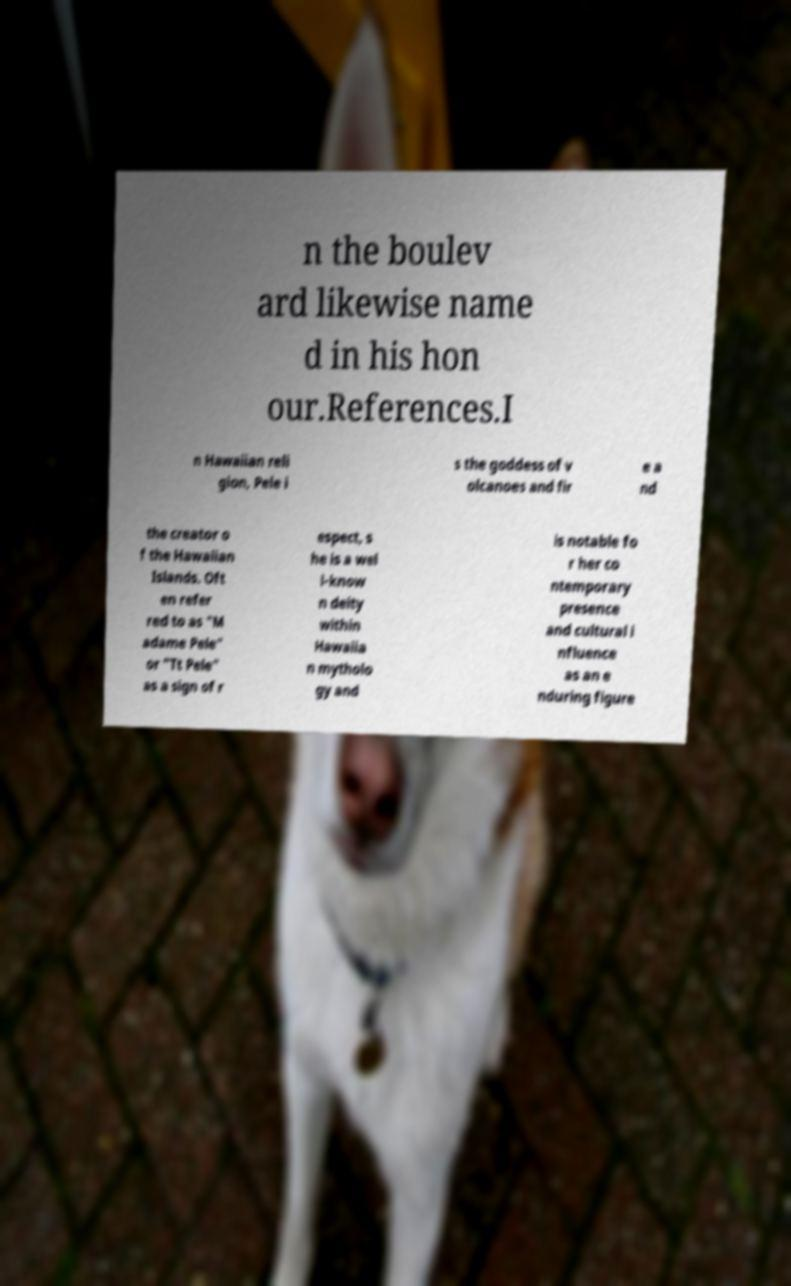Can you read and provide the text displayed in the image?This photo seems to have some interesting text. Can you extract and type it out for me? n the boulev ard likewise name d in his hon our.References.I n Hawaiian reli gion, Pele i s the goddess of v olcanoes and fir e a nd the creator o f the Hawaiian Islands. Oft en refer red to as "M adame Pele" or "Tt Pele" as a sign of r espect, s he is a wel l-know n deity within Hawaiia n mytholo gy and is notable fo r her co ntemporary presence and cultural i nfluence as an e nduring figure 